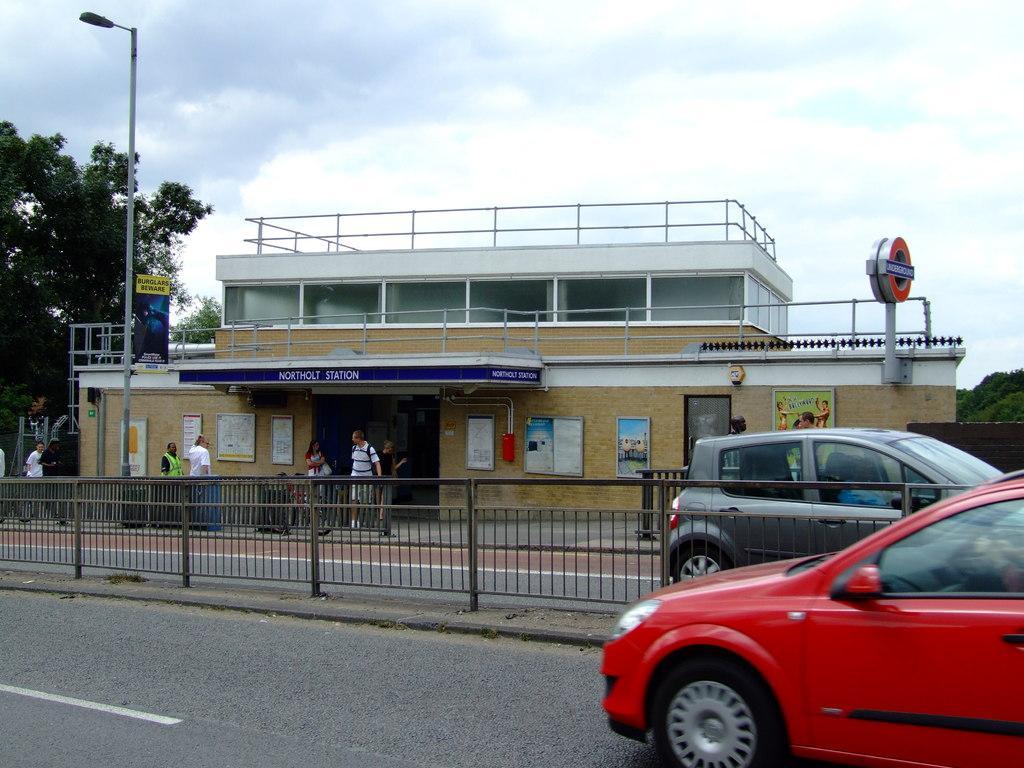Can you describe this image briefly? In this image on the right side we can see a car on the road at the fence and to other side of the fence we can see a person is riding car on the road. In the background we can see few persons are standing, buildings, boards and objects on the walls, fences, trees, board on a street light pole and clouds in the sky. 